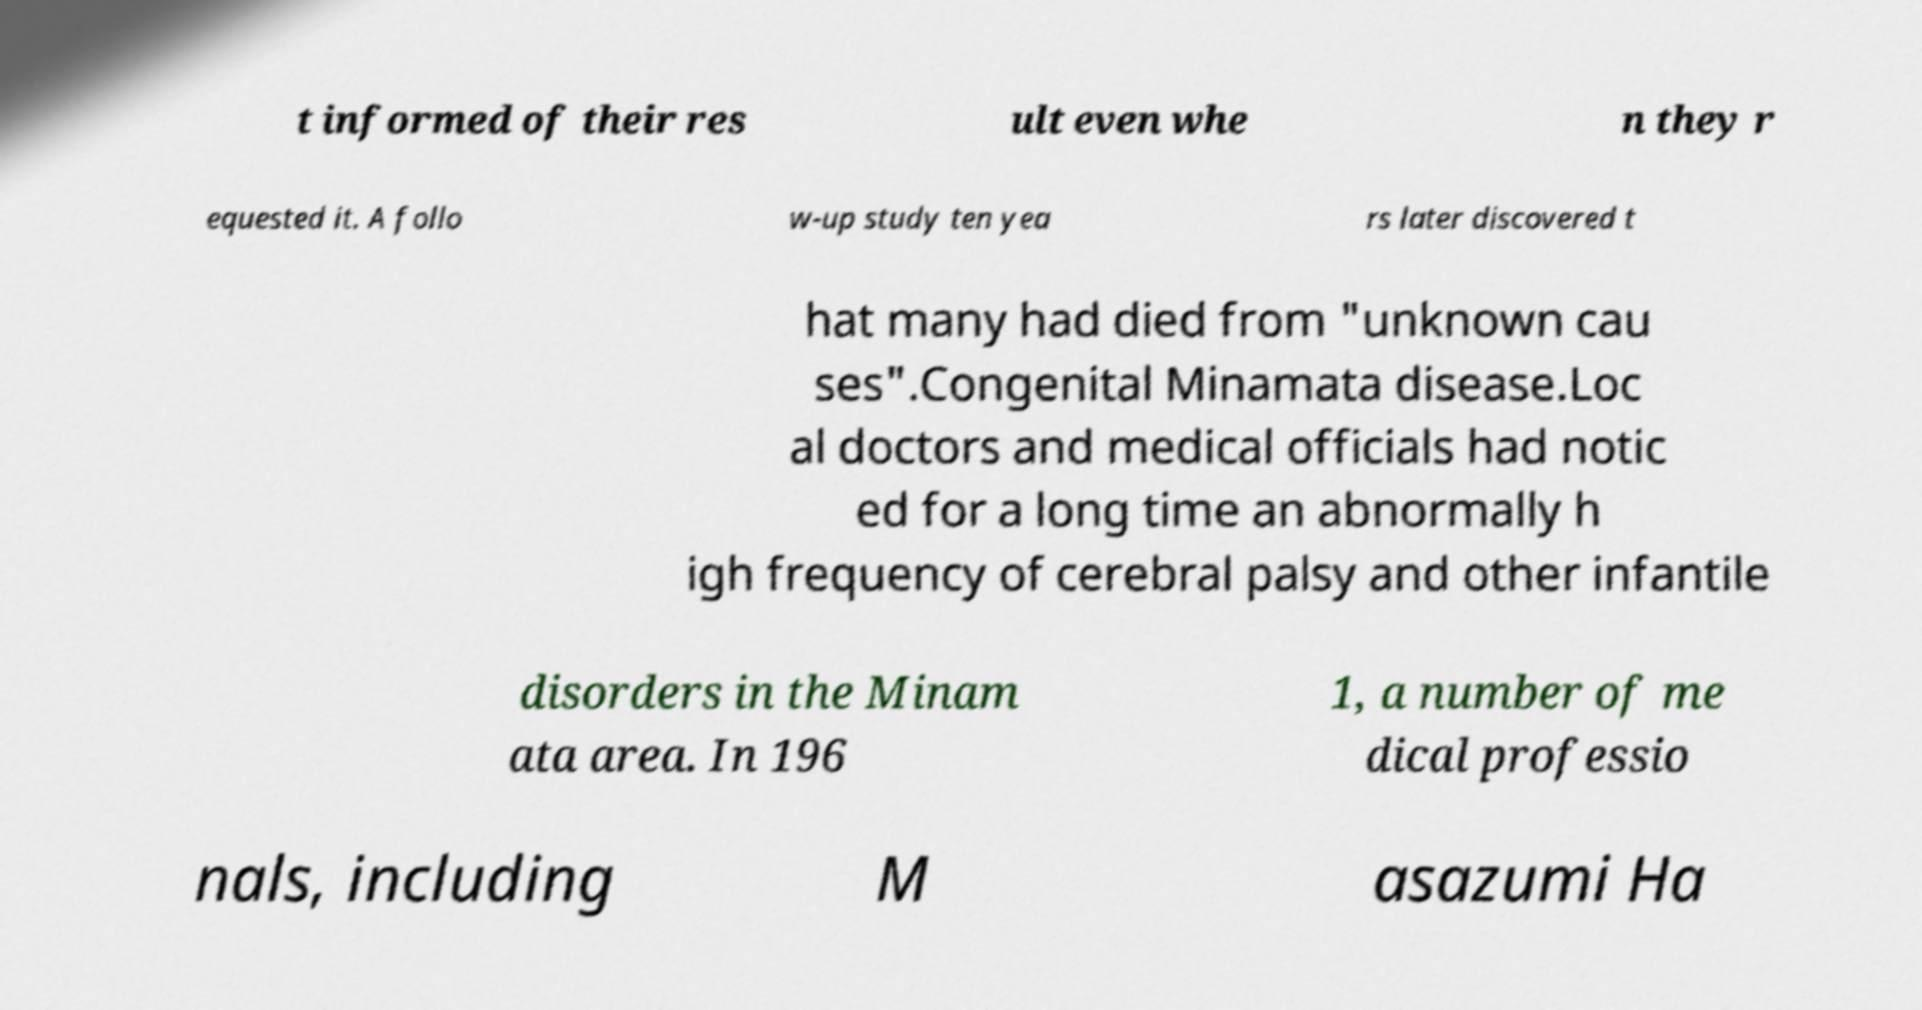I need the written content from this picture converted into text. Can you do that? t informed of their res ult even whe n they r equested it. A follo w-up study ten yea rs later discovered t hat many had died from "unknown cau ses".Congenital Minamata disease.Loc al doctors and medical officials had notic ed for a long time an abnormally h igh frequency of cerebral palsy and other infantile disorders in the Minam ata area. In 196 1, a number of me dical professio nals, including M asazumi Ha 